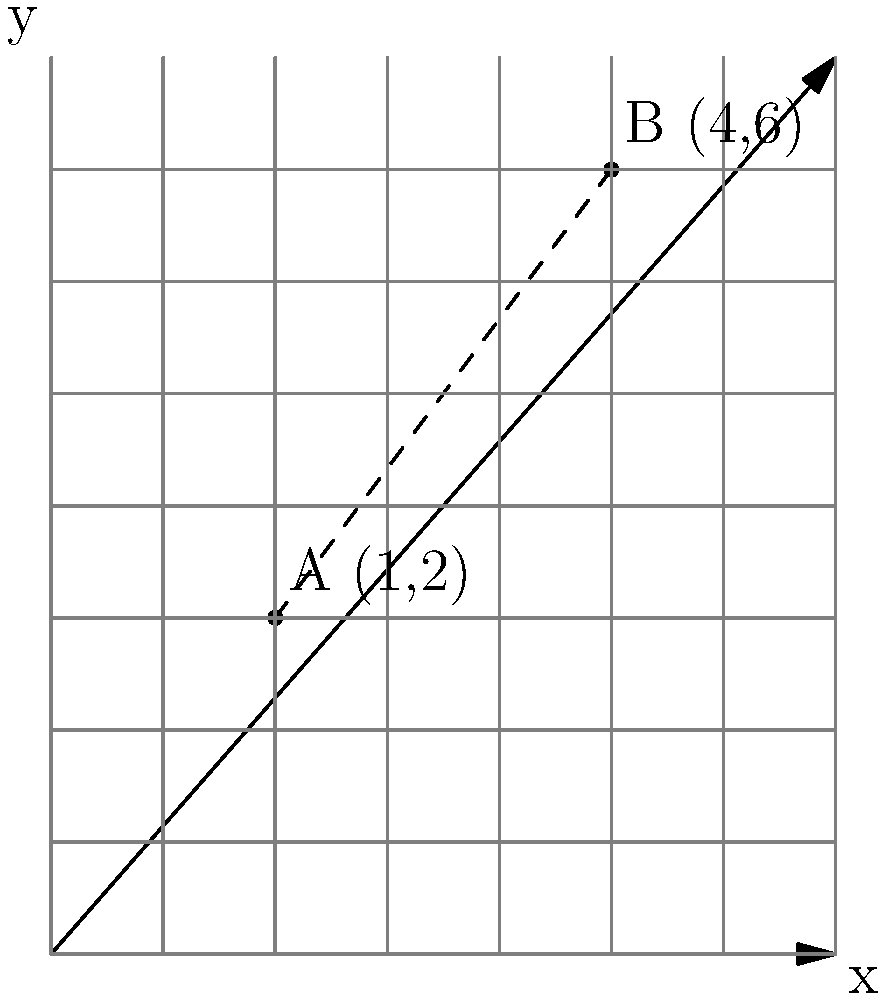In a therapeutic horse stable layout, two horse stalls are represented by points A(1,2) and B(4,6) on a coordinate plane. Calculate the distance between these two stalls to ensure proper spacing for the therapy sessions. To find the distance between two points, we can use the distance formula derived from the Pythagorean theorem:

$$d = \sqrt{(x_2 - x_1)^2 + (y_2 - y_1)^2}$$

Where $(x_1, y_1)$ represents the coordinates of point A, and $(x_2, y_2)$ represents the coordinates of point B.

Step 1: Identify the coordinates
A(1,2) and B(4,6)
$x_1 = 1, y_1 = 2$
$x_2 = 4, y_2 = 6$

Step 2: Plug the values into the distance formula
$$d = \sqrt{(4 - 1)^2 + (6 - 2)^2}$$

Step 3: Simplify the expressions inside the parentheses
$$d = \sqrt{3^2 + 4^2}$$

Step 4: Calculate the squares
$$d = \sqrt{9 + 16}$$

Step 5: Add the values under the square root
$$d = \sqrt{25}$$

Step 6: Simplify the square root
$$d = 5$$

Therefore, the distance between the two horse stalls is 5 units.
Answer: 5 units 